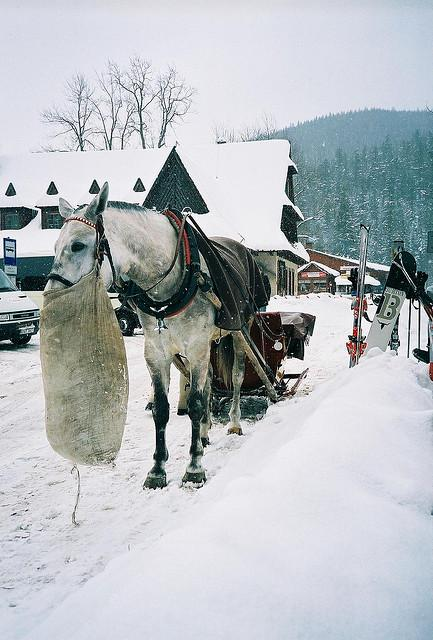The animal has how many legs? four 